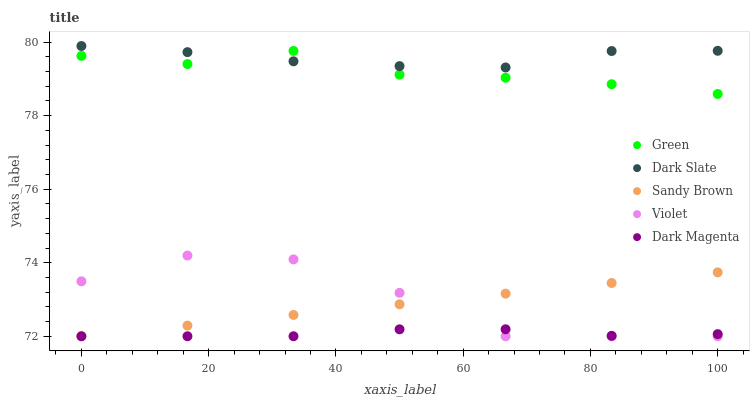Does Dark Magenta have the minimum area under the curve?
Answer yes or no. Yes. Does Dark Slate have the maximum area under the curve?
Answer yes or no. Yes. Does Green have the minimum area under the curve?
Answer yes or no. No. Does Green have the maximum area under the curve?
Answer yes or no. No. Is Sandy Brown the smoothest?
Answer yes or no. Yes. Is Violet the roughest?
Answer yes or no. Yes. Is Green the smoothest?
Answer yes or no. No. Is Green the roughest?
Answer yes or no. No. Does Dark Magenta have the lowest value?
Answer yes or no. Yes. Does Green have the lowest value?
Answer yes or no. No. Does Dark Slate have the highest value?
Answer yes or no. Yes. Does Green have the highest value?
Answer yes or no. No. Is Violet less than Green?
Answer yes or no. Yes. Is Green greater than Violet?
Answer yes or no. Yes. Does Violet intersect Sandy Brown?
Answer yes or no. Yes. Is Violet less than Sandy Brown?
Answer yes or no. No. Is Violet greater than Sandy Brown?
Answer yes or no. No. Does Violet intersect Green?
Answer yes or no. No. 